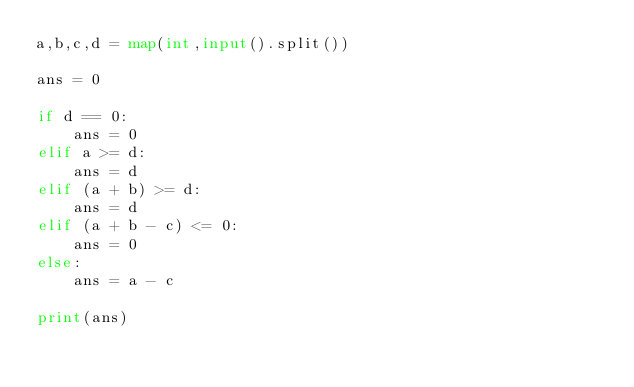<code> <loc_0><loc_0><loc_500><loc_500><_Python_>a,b,c,d = map(int,input().split())

ans = 0

if d == 0:
    ans = 0
elif a >= d:
    ans = d
elif (a + b) >= d:
    ans = d
elif (a + b - c) <= 0:
    ans = 0
else:
    ans = a - c

print(ans)</code> 